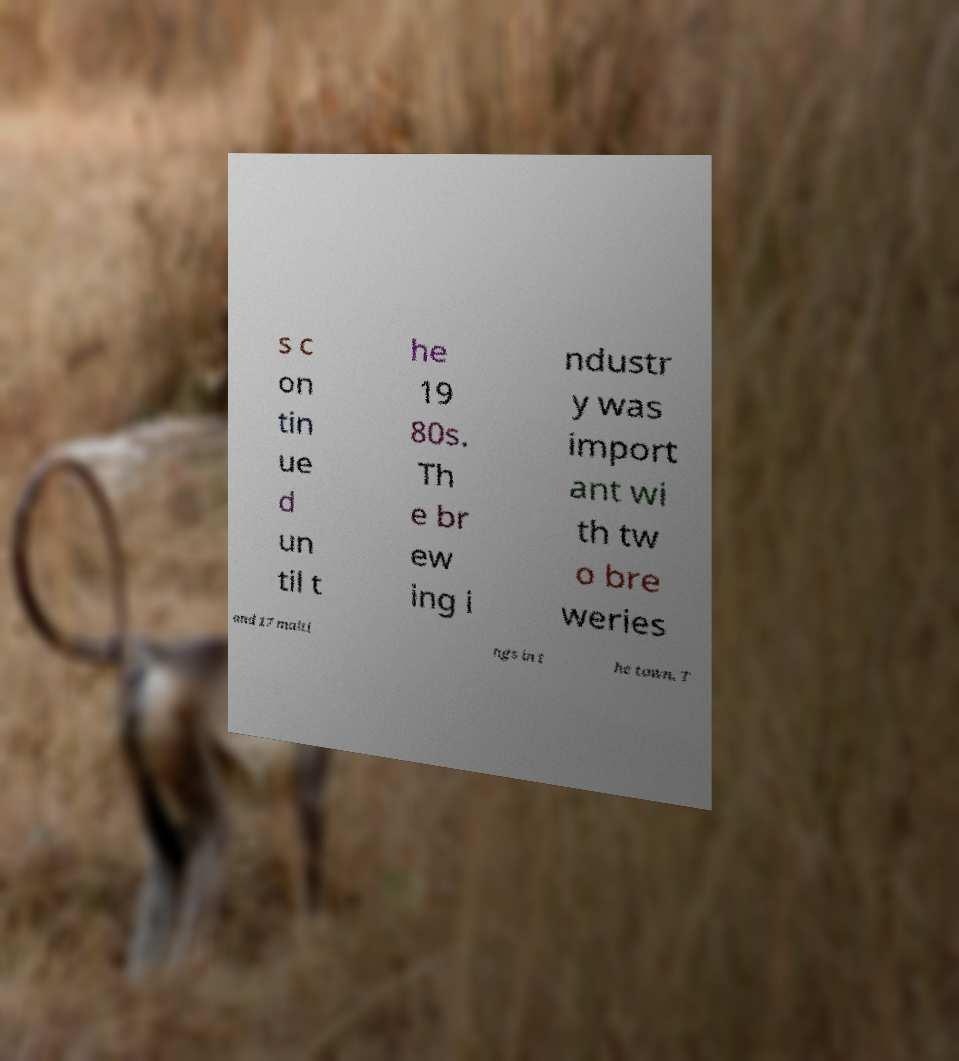Please read and relay the text visible in this image. What does it say? s c on tin ue d un til t he 19 80s. Th e br ew ing i ndustr y was import ant wi th tw o bre weries and 17 malti ngs in t he town. T 